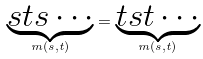<formula> <loc_0><loc_0><loc_500><loc_500>\underbrace { s t s \cdots } _ { m ( s , t ) } = \underbrace { t s t \cdots } _ { m ( s , t ) }</formula> 